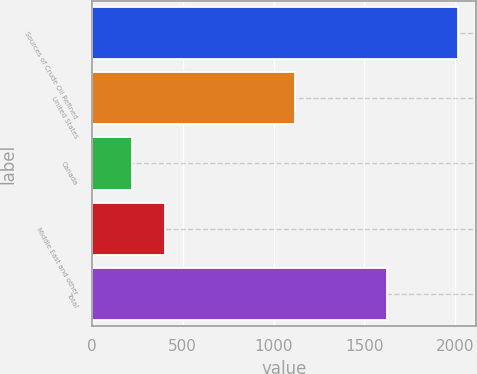Convert chart to OTSL. <chart><loc_0><loc_0><loc_500><loc_500><bar_chart><fcel>Sources of Crude Oil Refined<fcel>United States<fcel>Canada<fcel>Middle East and other<fcel>Total<nl><fcel>2014<fcel>1120<fcel>223<fcel>402.1<fcel>1622<nl></chart> 